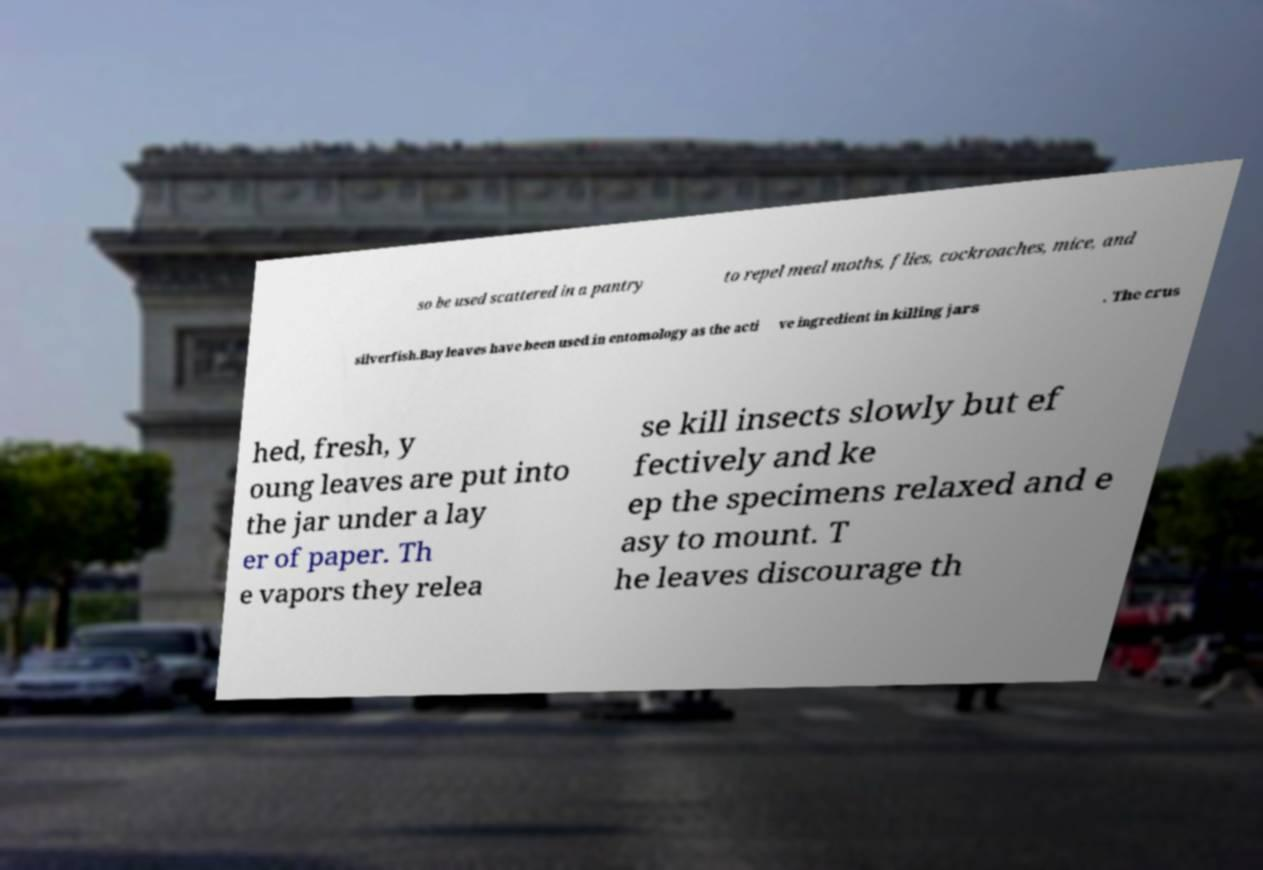Can you accurately transcribe the text from the provided image for me? so be used scattered in a pantry to repel meal moths, flies, cockroaches, mice, and silverfish.Bay leaves have been used in entomology as the acti ve ingredient in killing jars . The crus hed, fresh, y oung leaves are put into the jar under a lay er of paper. Th e vapors they relea se kill insects slowly but ef fectively and ke ep the specimens relaxed and e asy to mount. T he leaves discourage th 